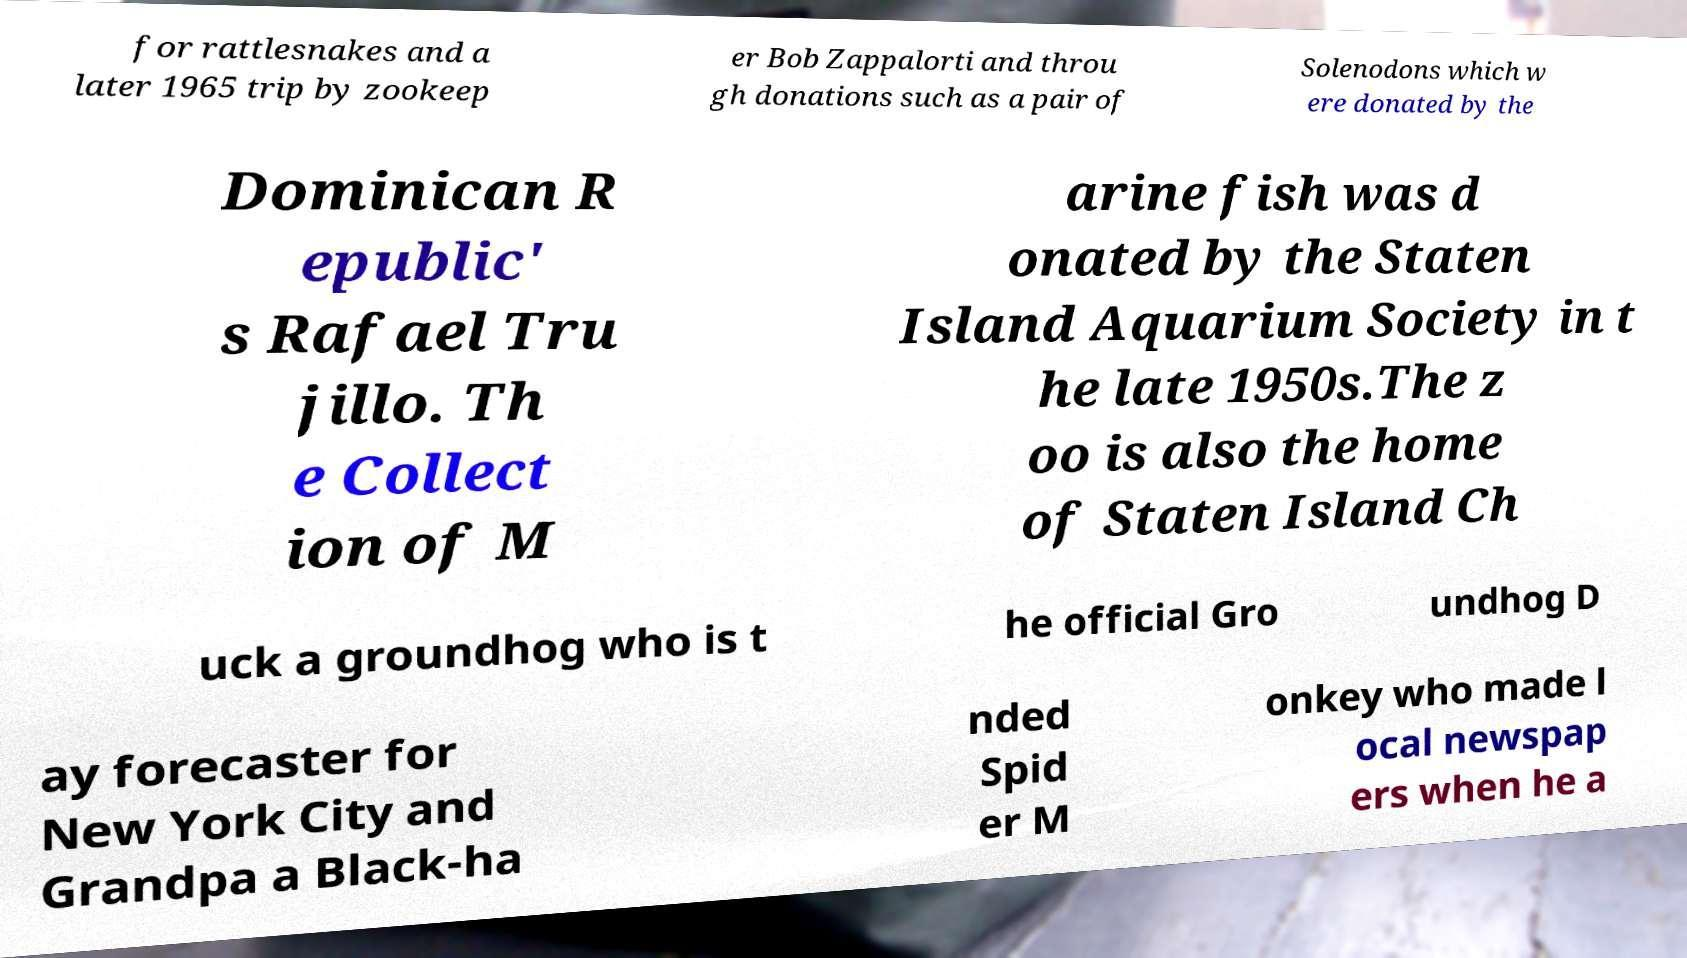I need the written content from this picture converted into text. Can you do that? for rattlesnakes and a later 1965 trip by zookeep er Bob Zappalorti and throu gh donations such as a pair of Solenodons which w ere donated by the Dominican R epublic' s Rafael Tru jillo. Th e Collect ion of M arine fish was d onated by the Staten Island Aquarium Society in t he late 1950s.The z oo is also the home of Staten Island Ch uck a groundhog who is t he official Gro undhog D ay forecaster for New York City and Grandpa a Black-ha nded Spid er M onkey who made l ocal newspap ers when he a 